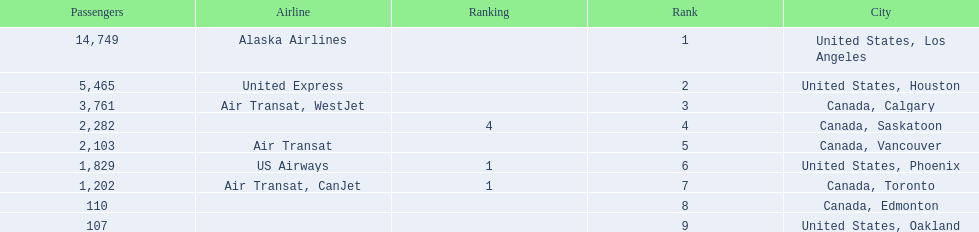Where are the destinations of the airport? United States, Los Angeles, United States, Houston, Canada, Calgary, Canada, Saskatoon, Canada, Vancouver, United States, Phoenix, Canada, Toronto, Canada, Edmonton, United States, Oakland. What is the number of passengers to phoenix? 1,829. 